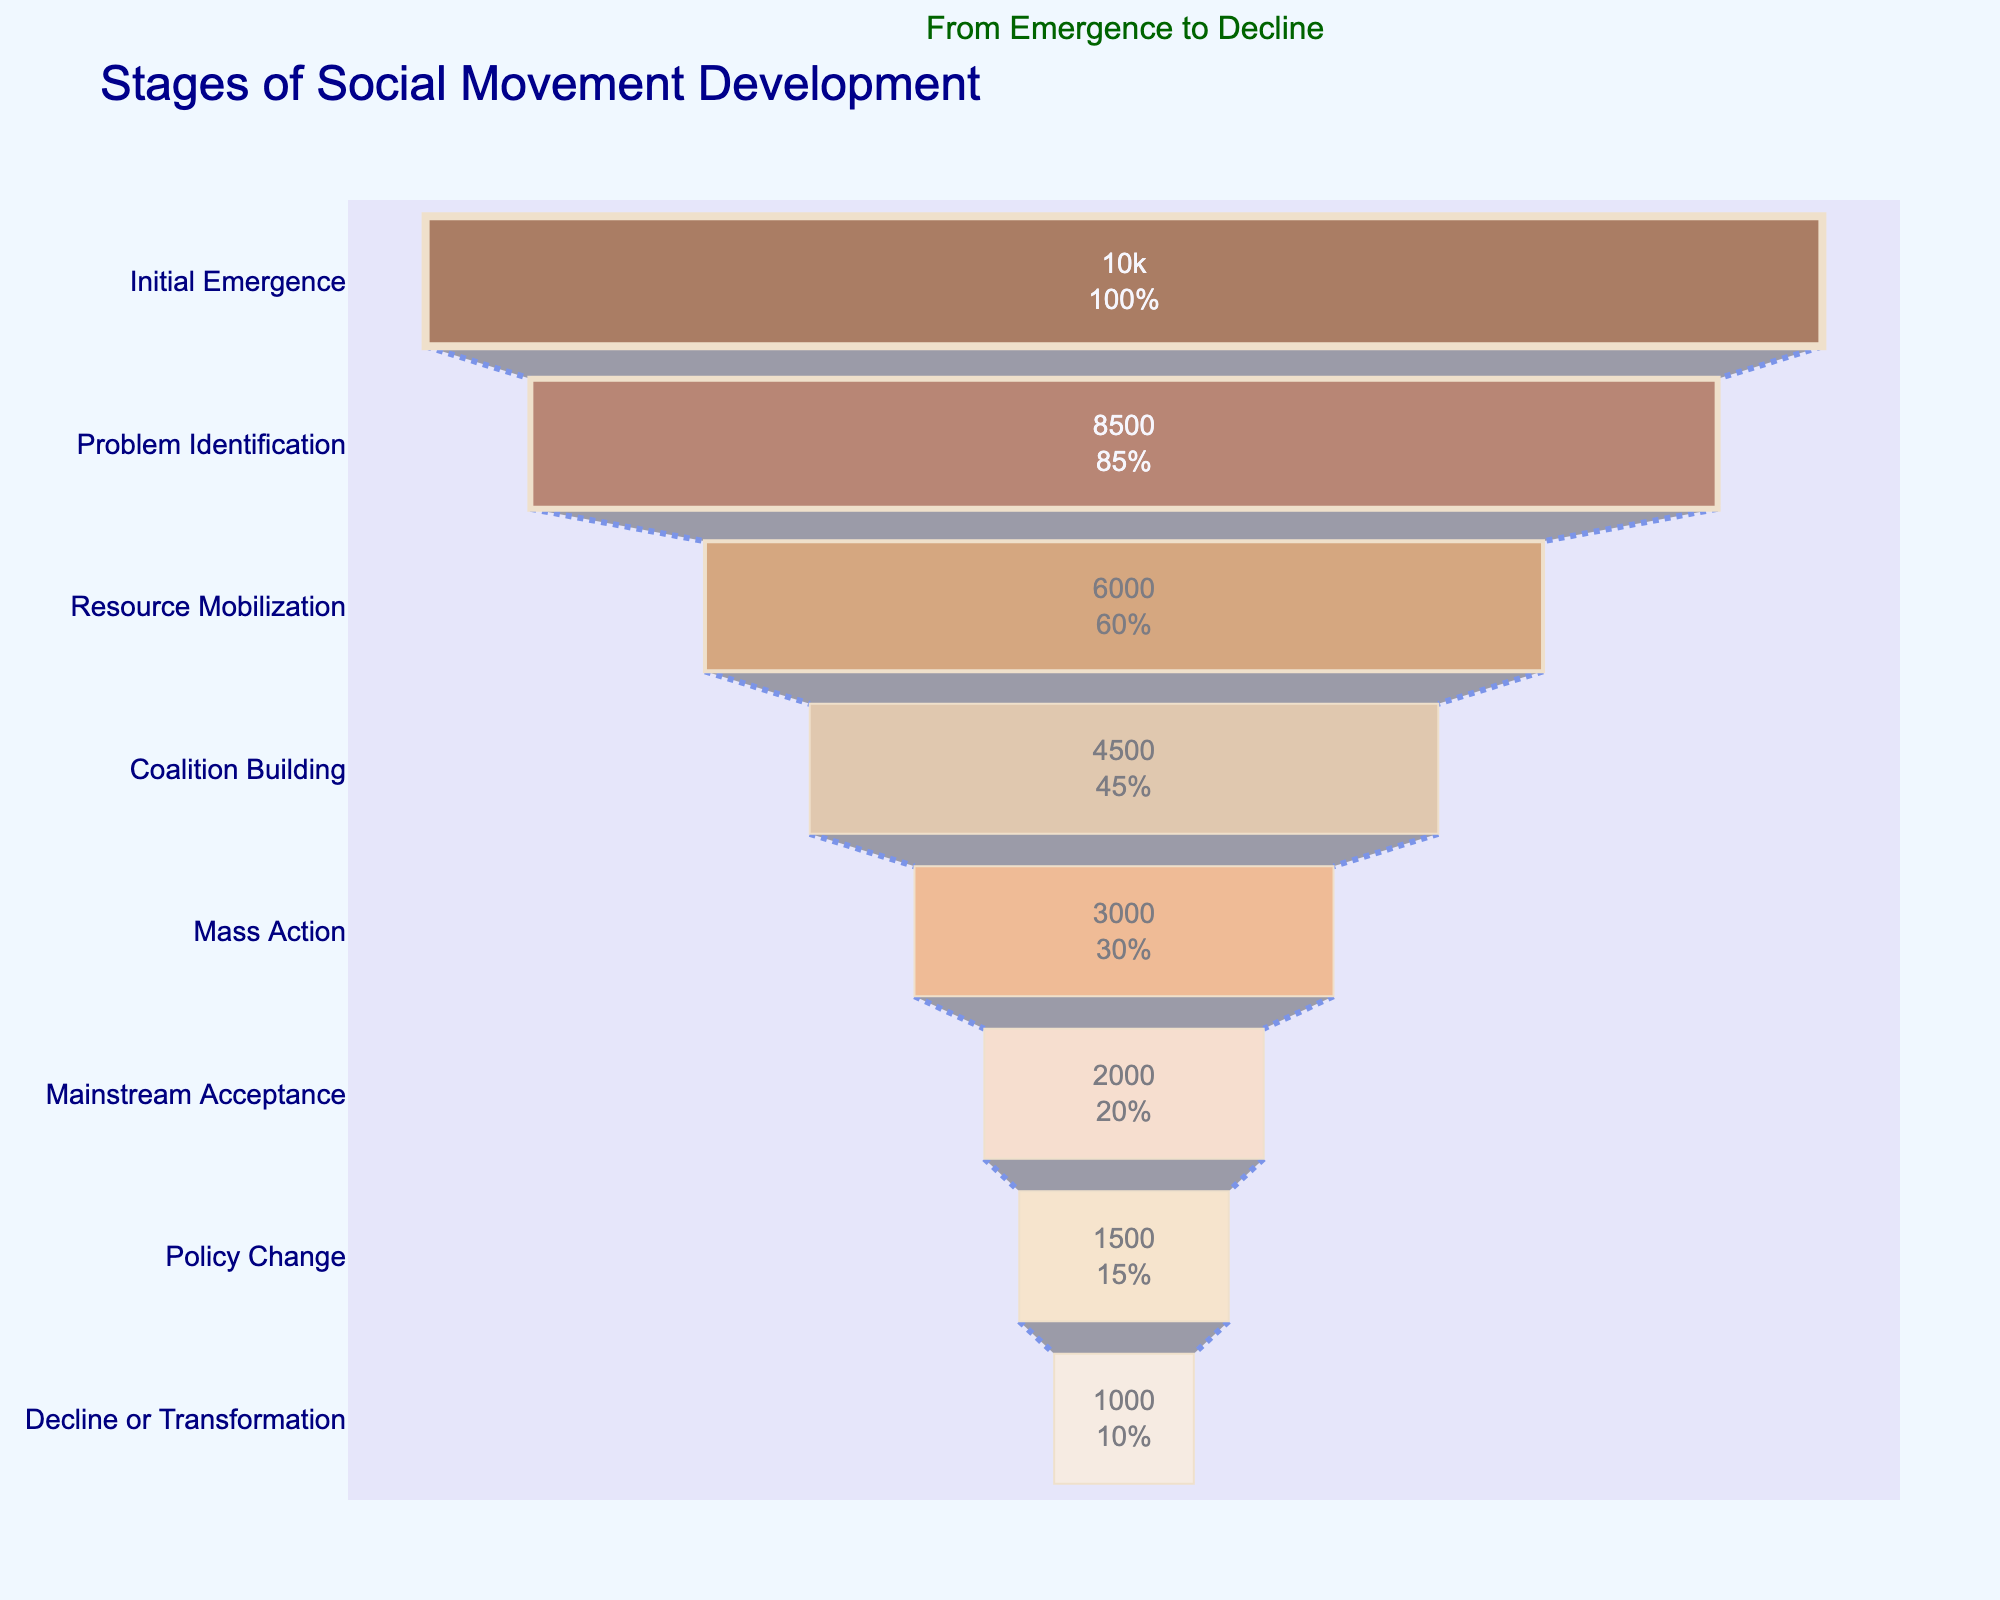what is the title of the figure? The title is located at the top of the figure and reads "Stages of Social Movement Development".
Answer: Stages of Social Movement Development What is the number of participants at the Problem Identification stage? The stage "Problem Identification" shows the number of participants in text inside the bar.
Answer: 8500 Compare the number of participants in the Initial Emergence and Mainstream Acceptance stages. Which stage has more participants and by how much? The Initial Emergence stage has 10000 participants, and the Mainstream Acceptance stage has 2000 participants. To find the difference, subtract 2000 from 10000.
Answer: Initial Emergence has more participants by 8000 What percentage of the initial participants reach the Mass Action stage? In the bar for the Mass Action stage, the text shows both the value and the percentage. The text indicates 3000 participants and the percentage relative to the initial number (10000).
Answer: 30% Is the number of participants at the Decline or Transformation stage greater than one-tenth of those at the Initial Emergence stage? The Decline or Transformation stage has 1000 participants, and one-tenth of the Initial Emergence stage (10000) is 1000. Since 1000 equals 1000, the number meets this condition.
Answer: Yes How many stages have more than half the initial participants? Half of the initial participants (10000) is 5000. Counting the stages with more than 5000 participants: Initial Emergence and Problem Identification.
Answer: 2 stages What is the combined number of participants at the Policy Change and Decline or Transformation stages? Add the number of participants in the Policy Change stage (1500) and Decline or Transformation stage (1000).
Answer: 2500 Which stage experiences the greatest drop in participants from the preceding stage? Compute the difference for each transition: Initial Emergence (10000) to Problem Identification (8500) is 1500, Problem Identification to Resource Mobilization (6000) is 2500, Resource Mobilization to Coalition Building (4500) is 1500, Coalition Building to Mass Action (3000) is 1500, Mass Action to Mainstream Acceptance (2000) is 1000, Mainstream Acceptance to Policy Change (1500) is 500, and Policy Change to Decline or Transformation (1000) is 500. The greatest drop is during Problem Identification to Resource Mobilization with 2500 participants.
Answer: From Problem Identification to Resource Mobilization, 2500 participants What is the average number of participants across all stages? Sum the participants at all stages (10000 + 8500 + 6000 + 4500 + 3000 + 2000 + 1500 + 1000) and divide by the number of stages (8). The total is 36500, so the average is 36500/8.
Answer: 4562.5 How many stages are depicted in the funnel chart? Count the number of stages listed on the y-axis or the bars in the funnel chart.
Answer: 8 